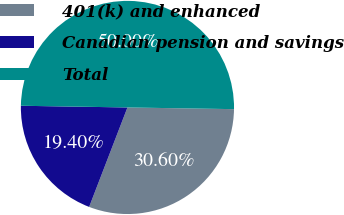<chart> <loc_0><loc_0><loc_500><loc_500><pie_chart><fcel>401(k) and enhanced<fcel>Canadian pension and savings<fcel>Total<nl><fcel>30.6%<fcel>19.4%<fcel>50.0%<nl></chart> 